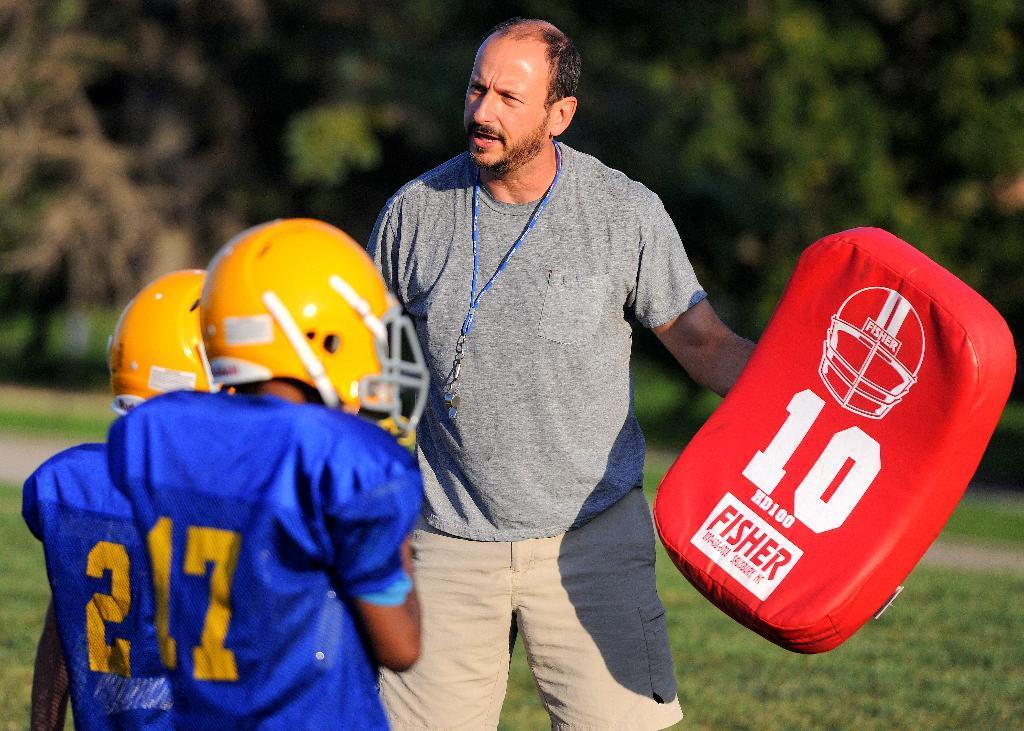Can you describe this image briefly? In the middle a man is there, he is holding a red color thing in his hand, on the left side there are 2 players. 